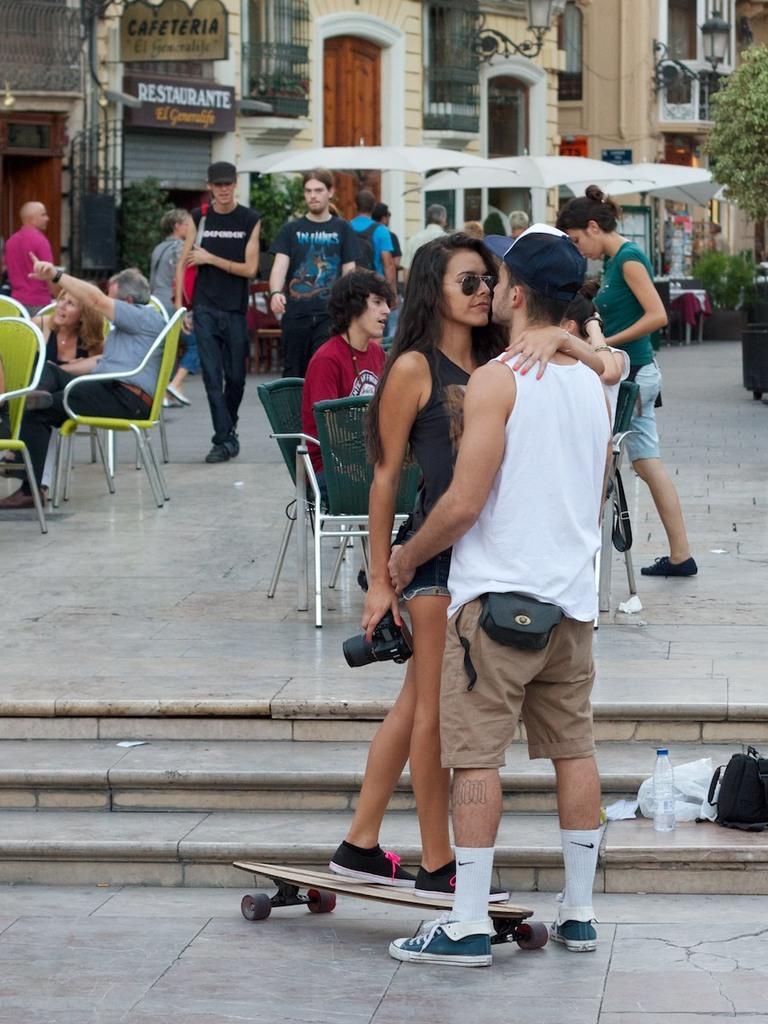Can you describe this image briefly? I can see a woman standing on the skateboard and holding a camera. And here is the man standing and holding the women. I can see a water bottle,a black color bag and white color polythene bag. At background I can see few people sitting on the chairs and few people are walking. This is a building with a lamp attached to the building and this is a door. Here is the name board. This looks like a tree. 